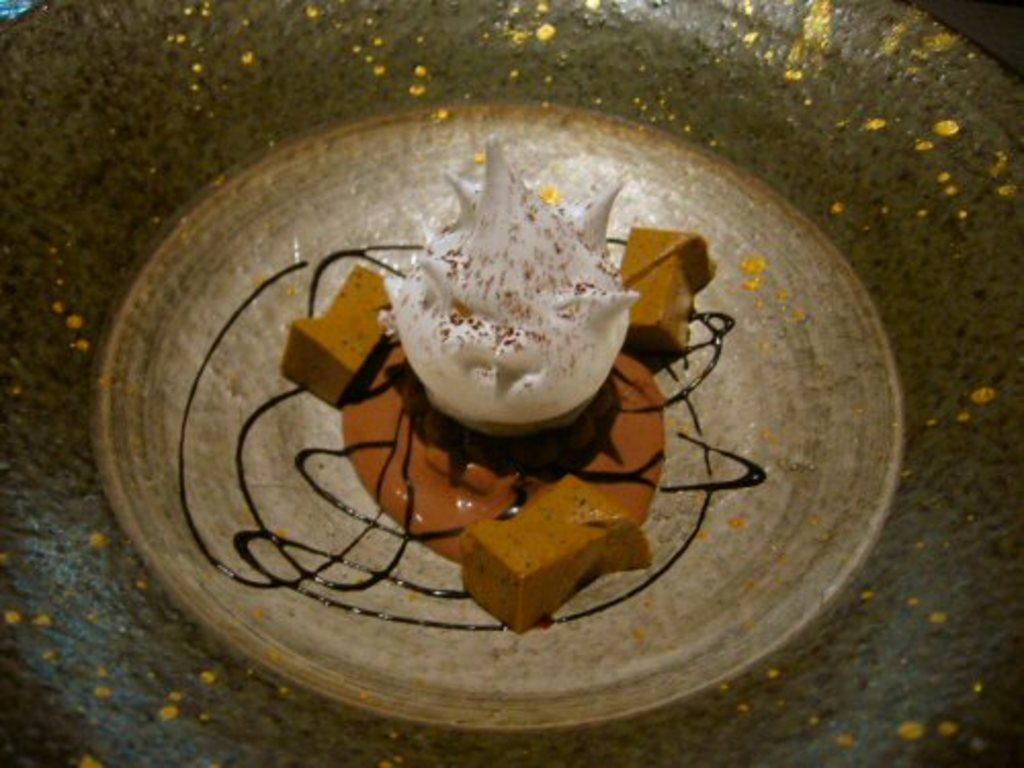What is present in the image that resembles a container? There is a bowl in the image. What is inside the bowl? There is a food item in the bowl. Can you describe the appearance of the food item? There is cream on the food item. What type of chair can be seen in the image? There is no chair present in the image. Is there a sweater draped over the food item in the image? There is no sweater present in the image. 